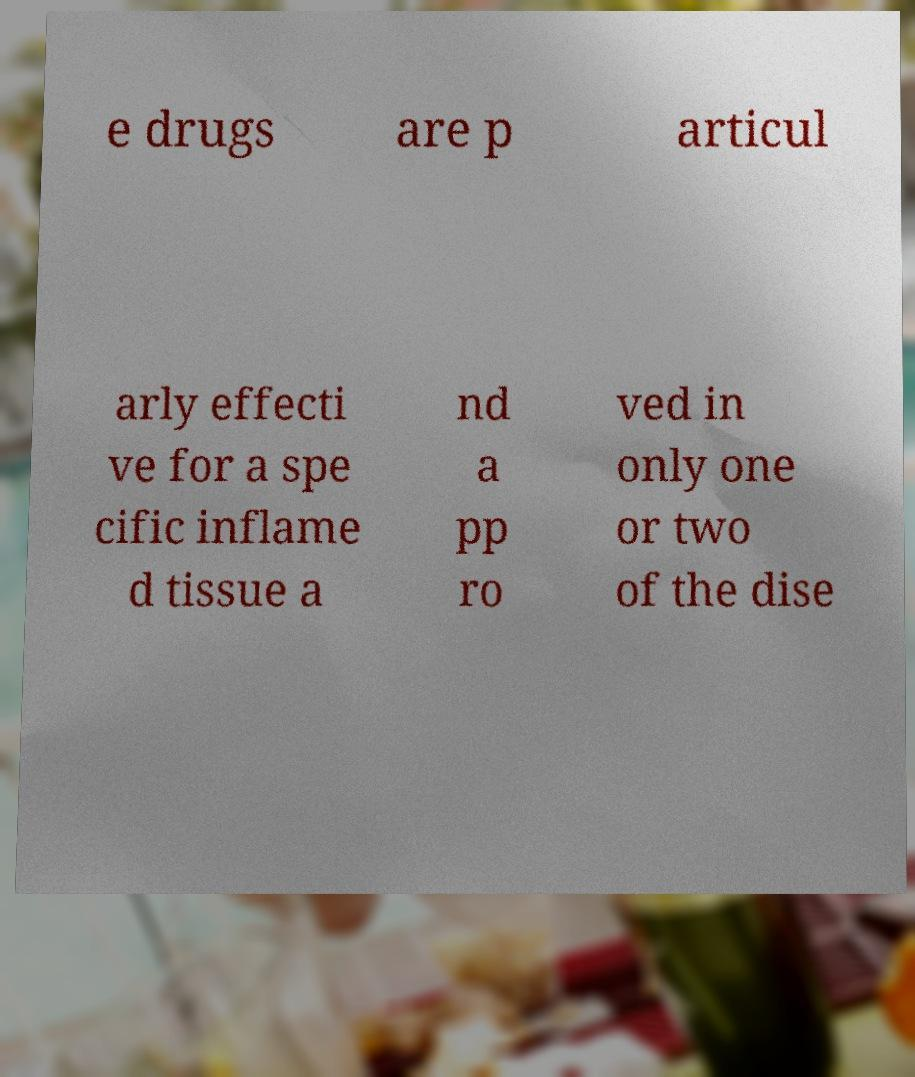Can you accurately transcribe the text from the provided image for me? e drugs are p articul arly effecti ve for a spe cific inflame d tissue a nd a pp ro ved in only one or two of the dise 